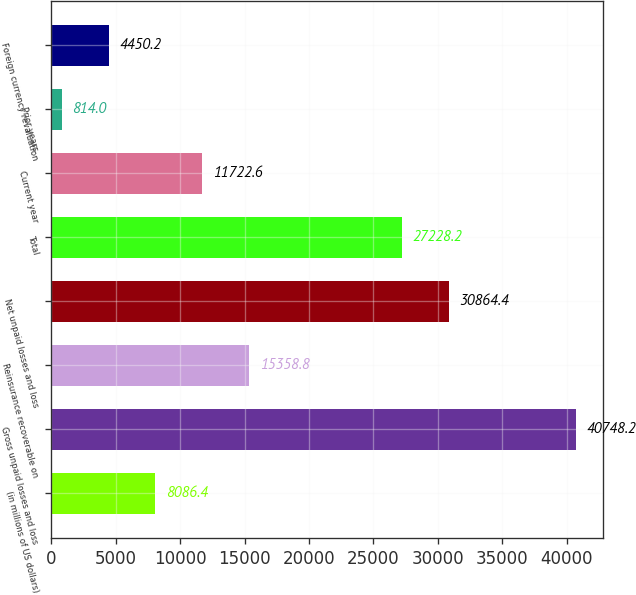<chart> <loc_0><loc_0><loc_500><loc_500><bar_chart><fcel>(in millions of US dollars)<fcel>Gross unpaid losses and loss<fcel>Reinsurance recoverable on<fcel>Net unpaid losses and loss<fcel>Total<fcel>Current year<fcel>Prior years<fcel>Foreign currency revaluation<nl><fcel>8086.4<fcel>40748.2<fcel>15358.8<fcel>30864.4<fcel>27228.2<fcel>11722.6<fcel>814<fcel>4450.2<nl></chart> 